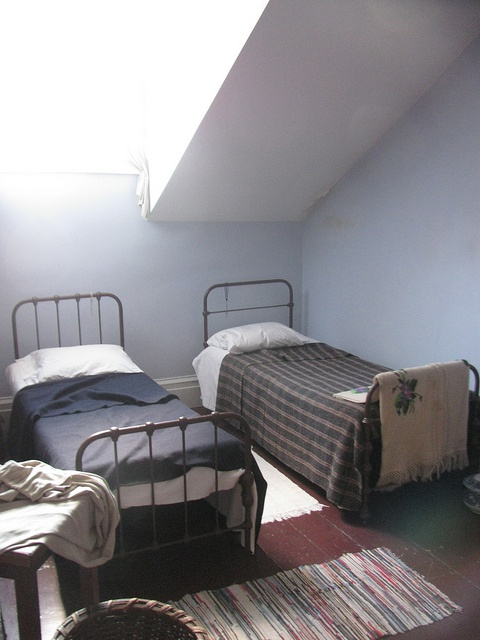Describe the objects in this image and their specific colors. I can see bed in white, gray, black, darkgray, and lightgray tones and bed in white, black, darkgray, gray, and lightgray tones in this image. 